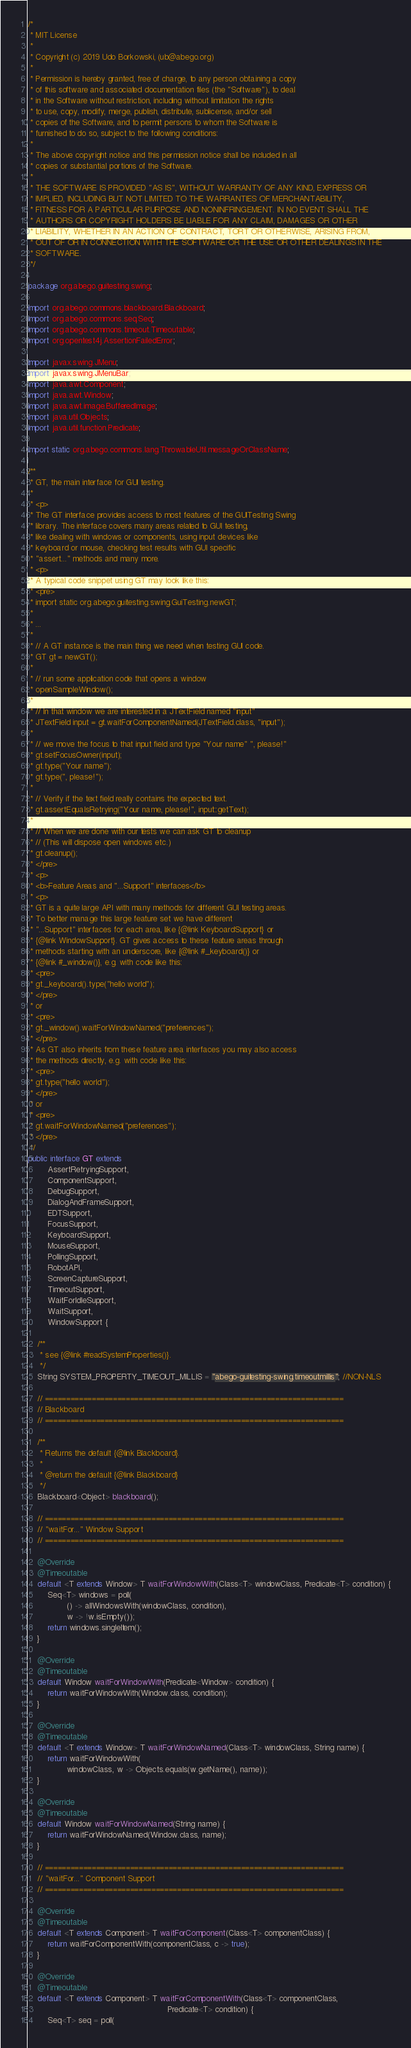Convert code to text. <code><loc_0><loc_0><loc_500><loc_500><_Java_>/*
 * MIT License
 *
 * Copyright (c) 2019 Udo Borkowski, (ub@abego.org)
 *
 * Permission is hereby granted, free of charge, to any person obtaining a copy
 * of this software and associated documentation files (the "Software"), to deal
 * in the Software without restriction, including without limitation the rights
 * to use, copy, modify, merge, publish, distribute, sublicense, and/or sell
 * copies of the Software, and to permit persons to whom the Software is
 * furnished to do so, subject to the following conditions:
 *
 * The above copyright notice and this permission notice shall be included in all
 * copies or substantial portions of the Software.
 *
 * THE SOFTWARE IS PROVIDED "AS IS", WITHOUT WARRANTY OF ANY KIND, EXPRESS OR
 * IMPLIED, INCLUDING BUT NOT LIMITED TO THE WARRANTIES OF MERCHANTABILITY,
 * FITNESS FOR A PARTICULAR PURPOSE AND NONINFRINGEMENT. IN NO EVENT SHALL THE
 * AUTHORS OR COPYRIGHT HOLDERS BE LIABLE FOR ANY CLAIM, DAMAGES OR OTHER
 * LIABILITY, WHETHER IN AN ACTION OF CONTRACT, TORT OR OTHERWISE, ARISING FROM,
 * OUT OF OR IN CONNECTION WITH THE SOFTWARE OR THE USE OR OTHER DEALINGS IN THE
 * SOFTWARE.
 */

package org.abego.guitesting.swing;

import org.abego.commons.blackboard.Blackboard;
import org.abego.commons.seq.Seq;
import org.abego.commons.timeout.Timeoutable;
import org.opentest4j.AssertionFailedError;

import javax.swing.JMenu;
import javax.swing.JMenuBar;
import java.awt.Component;
import java.awt.Window;
import java.awt.image.BufferedImage;
import java.util.Objects;
import java.util.function.Predicate;

import static org.abego.commons.lang.ThrowableUtil.messageOrClassName;

/**
 * GT, the main interface for GUI testing.
 *
 * <p>
 * The GT interface provides access to most features of the GUITesting Swing
 * library. The interface covers many areas related to GUI testing,
 * like dealing with windows or components, using input devices like
 * keyboard or mouse, checking test results with GUI specific
 * "assert..." methods and many more.
 * <p>
 * A typical code snippet using GT may look like this:
 * <pre>
 * import static org.abego.guitesting.swing.GuiTesting.newGT;
 *
 * ...
 *
 * // A GT instance is the main thing we need when testing GUI code.
 * GT gt = newGT();
 *
 * // run some application code that opens a window
 * openSampleWindow();
 *
 * // In that window we are interested in a JTextField named "input"
 * JTextField input = gt.waitForComponentNamed(JTextField.class, "input");
 *
 * // we move the focus to that input field and type "Your name" ", please!"
 * gt.setFocusOwner(input);
 * gt.type("Your name");
 * gt.type(", please!");
 *
 * // Verify if the text field really contains the expected text.
 * gt.assertEqualsRetrying("Your name, please!", input::getText);
 *
 * // When we are done with our tests we can ask GT to cleanup
 * // (This will dispose open windows etc.)
 * gt.cleanup();
 * </pre>
 * <p>
 * <b>Feature Areas and "...Support" interfaces</b>
 * <p>
 * GT is a quite large API with many methods for different GUI testing areas.
 * To better manage this large feature set we have different
 * "...Support" interfaces for each area, like {@link KeyboardSupport} or
 * {@link WindowSupport}. GT gives access to these feature areas through
 * methods starting with an underscore, like {@link #_keyboard()} or
 * {@link #_window()}, e.g. with code like this:
 * <pre>
 * gt._keyboard().type("hello world");
 * </pre>
 * or
 * <pre>
 * gt._window().waitForWindowNamed("preferences");
 * </pre>
 * As GT also inherits from these feature area interfaces you may also access
 * the methods directly, e.g. with code like this:
 * <pre>
 * gt.type("hello world");
 * </pre>
 * or
 * <pre>
 * gt.waitForWindowNamed("preferences");
 * </pre>
 */
public interface GT extends
        AssertRetryingSupport,
        ComponentSupport,
        DebugSupport,
        DialogAndFrameSupport,
        EDTSupport,
        FocusSupport,
        KeyboardSupport,
        MouseSupport,
        PollingSupport,
        RobotAPI,
        ScreenCaptureSupport,
        TimeoutSupport,
        WaitForIdleSupport,
        WaitSupport,
        WindowSupport {

    /**
     * see {@link #readSystemProperties()}.
     */
    String SYSTEM_PROPERTY_TIMEOUT_MILLIS = "abego-guitesting-swing.timeoutmillis"; //NON-NLS

    // ======================================================================
    // Blackboard
    // ======================================================================

    /**
     * Returns the default {@link Blackboard}.
     *
     * @return the default {@link Blackboard}
     */
    Blackboard<Object> blackboard();

    // ======================================================================
    // "waitFor..." Window Support
    // ======================================================================

    @Override
    @Timeoutable
    default <T extends Window> T waitForWindowWith(Class<T> windowClass, Predicate<T> condition) {
        Seq<T> windows = poll(
                () -> allWindowsWith(windowClass, condition),
                w -> !w.isEmpty());
        return windows.singleItem();
    }

    @Override
    @Timeoutable
    default Window waitForWindowWith(Predicate<Window> condition) {
        return waitForWindowWith(Window.class, condition);
    }

    @Override
    @Timeoutable
    default <T extends Window> T waitForWindowNamed(Class<T> windowClass, String name) {
        return waitForWindowWith(
                windowClass, w -> Objects.equals(w.getName(), name));
    }

    @Override
    @Timeoutable
    default Window waitForWindowNamed(String name) {
        return waitForWindowNamed(Window.class, name);
    }

    // ======================================================================
    // "waitFor..." Component Support
    // ======================================================================

    @Override
    @Timeoutable
    default <T extends Component> T waitForComponent(Class<T> componentClass) {
        return waitForComponentWith(componentClass, c -> true);
    }

    @Override
    @Timeoutable
    default <T extends Component> T waitForComponentWith(Class<T> componentClass,
                                                         Predicate<T> condition) {
        Seq<T> seq = poll(</code> 